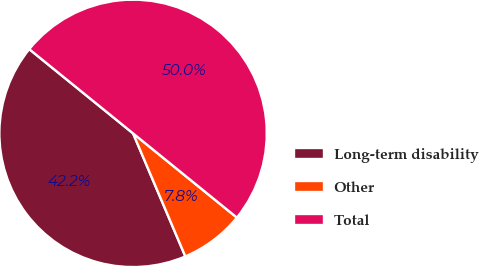Convert chart. <chart><loc_0><loc_0><loc_500><loc_500><pie_chart><fcel>Long-term disability<fcel>Other<fcel>Total<nl><fcel>42.24%<fcel>7.76%<fcel>50.0%<nl></chart> 